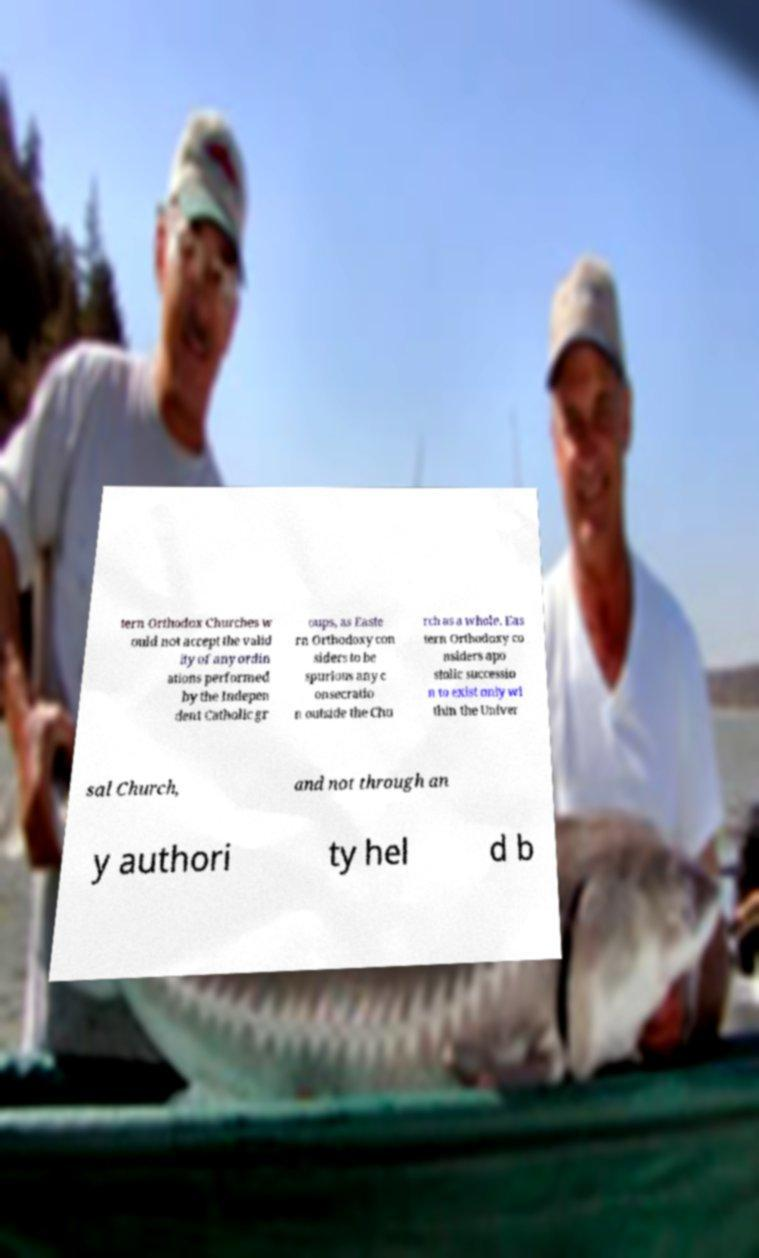Could you extract and type out the text from this image? tern Orthodox Churches w ould not accept the valid ity of any ordin ations performed by the Indepen dent Catholic gr oups, as Easte rn Orthodoxy con siders to be spurious any c onsecratio n outside the Chu rch as a whole. Eas tern Orthodoxy co nsiders apo stolic successio n to exist only wi thin the Univer sal Church, and not through an y authori ty hel d b 